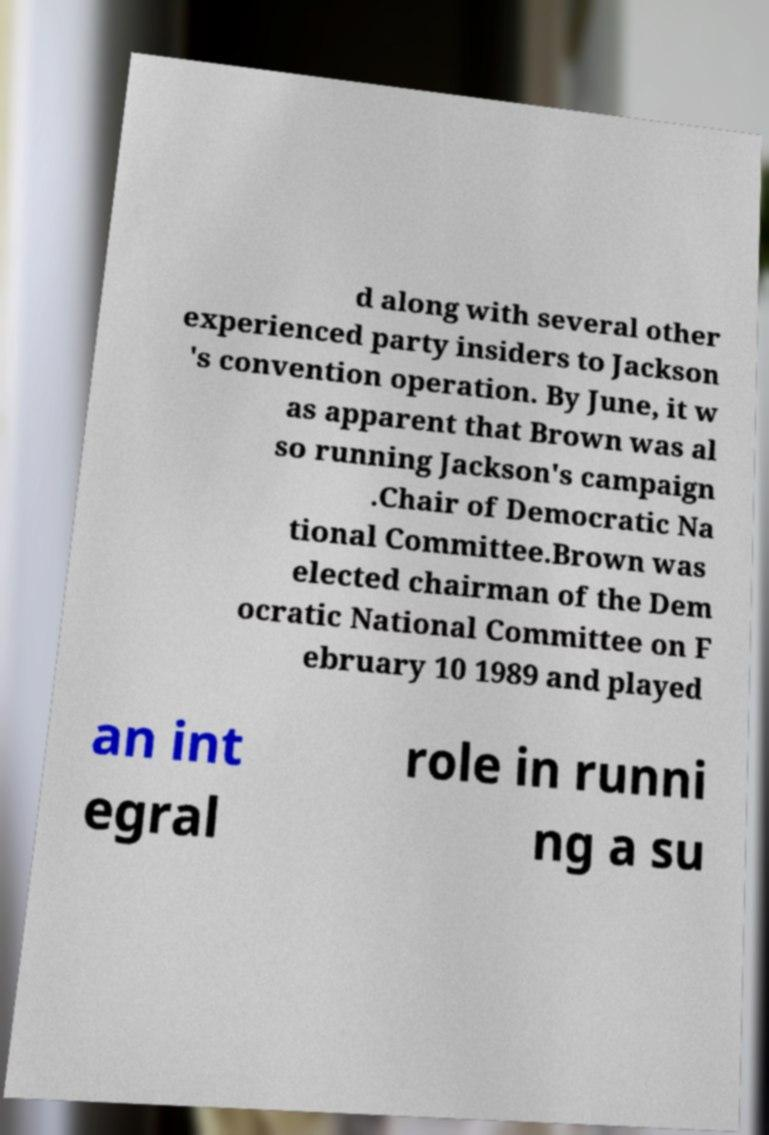I need the written content from this picture converted into text. Can you do that? d along with several other experienced party insiders to Jackson 's convention operation. By June, it w as apparent that Brown was al so running Jackson's campaign .Chair of Democratic Na tional Committee.Brown was elected chairman of the Dem ocratic National Committee on F ebruary 10 1989 and played an int egral role in runni ng a su 